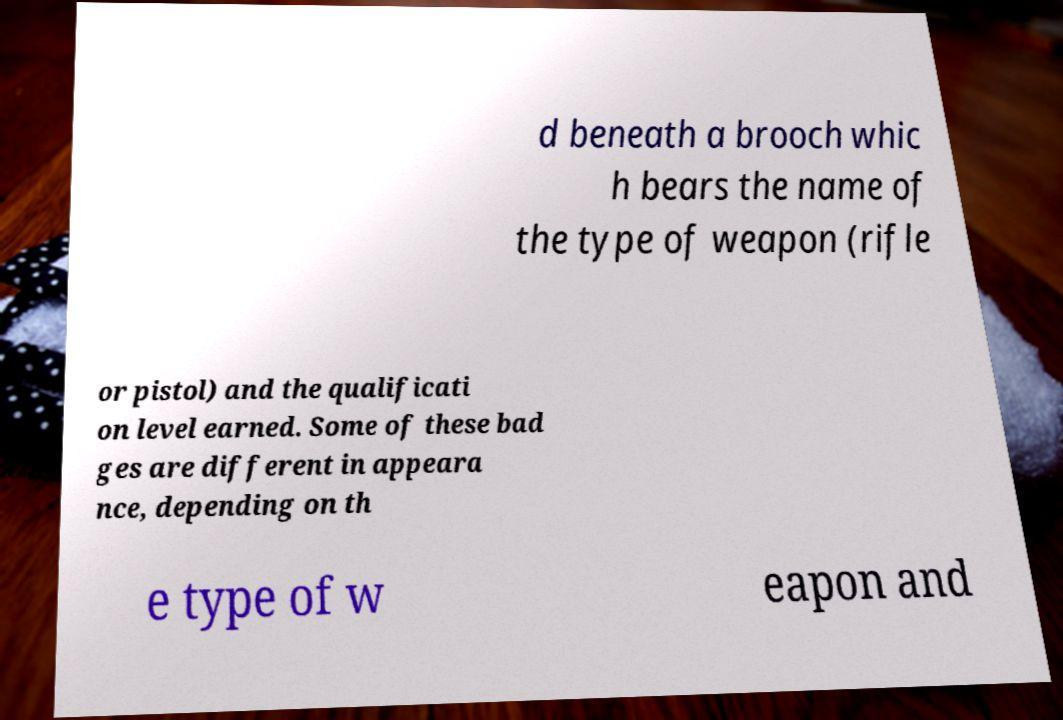Could you assist in decoding the text presented in this image and type it out clearly? d beneath a brooch whic h bears the name of the type of weapon (rifle or pistol) and the qualificati on level earned. Some of these bad ges are different in appeara nce, depending on th e type of w eapon and 